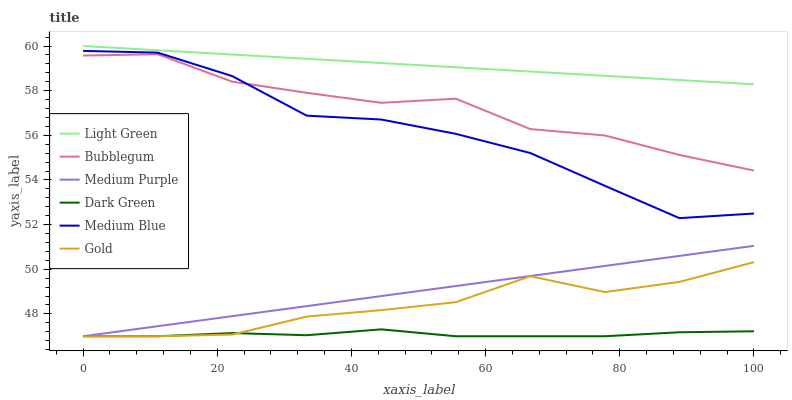Does Dark Green have the minimum area under the curve?
Answer yes or no. Yes. Does Light Green have the maximum area under the curve?
Answer yes or no. Yes. Does Medium Blue have the minimum area under the curve?
Answer yes or no. No. Does Medium Blue have the maximum area under the curve?
Answer yes or no. No. Is Medium Purple the smoothest?
Answer yes or no. Yes. Is Medium Blue the roughest?
Answer yes or no. Yes. Is Bubblegum the smoothest?
Answer yes or no. No. Is Bubblegum the roughest?
Answer yes or no. No. Does Gold have the lowest value?
Answer yes or no. Yes. Does Medium Blue have the lowest value?
Answer yes or no. No. Does Light Green have the highest value?
Answer yes or no. Yes. Does Medium Blue have the highest value?
Answer yes or no. No. Is Bubblegum less than Light Green?
Answer yes or no. Yes. Is Medium Blue greater than Gold?
Answer yes or no. Yes. Does Medium Purple intersect Gold?
Answer yes or no. Yes. Is Medium Purple less than Gold?
Answer yes or no. No. Is Medium Purple greater than Gold?
Answer yes or no. No. Does Bubblegum intersect Light Green?
Answer yes or no. No. 